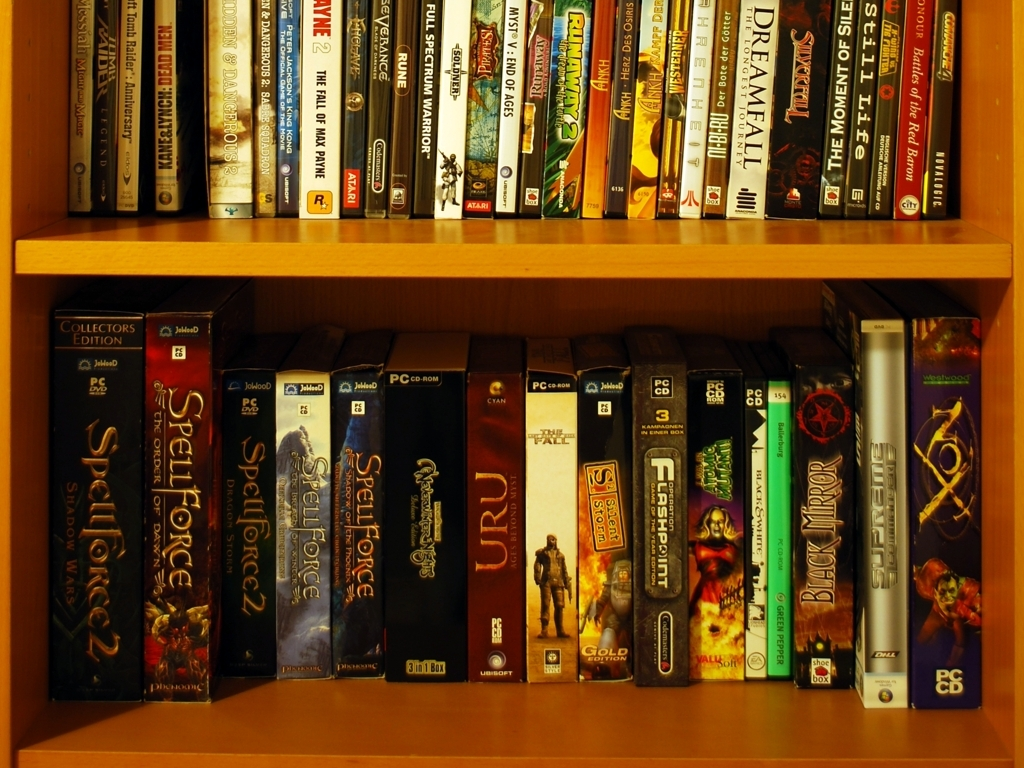What does this collection tell us about the owner's interests? This collection suggests that the owner has a keen interest in narrative-driven and strategy-focused games, which often provide rich, complex worlds and require thoughtful engagement. The owner might enjoy immersing themselves in alternative realities and exercising their decision-making skills through gameplay. 